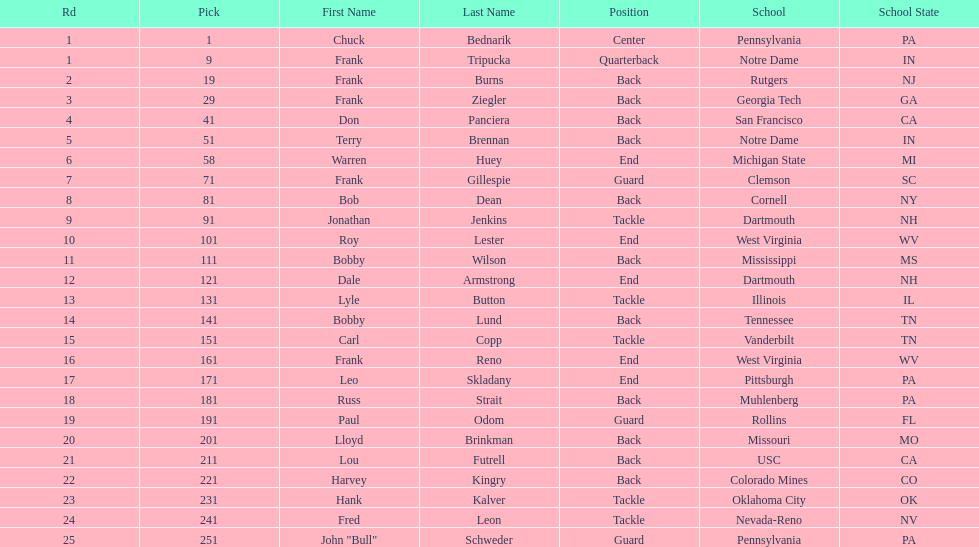What was the position that most of the players had? Back. Would you be able to parse every entry in this table? {'header': ['Rd', 'Pick', 'First Name', 'Last Name', 'Position', 'School', 'School State'], 'rows': [['1', '1', 'Chuck', 'Bednarik', 'Center', 'Pennsylvania', 'PA'], ['1', '9', 'Frank', 'Tripucka', 'Quarterback', 'Notre Dame', 'IN'], ['2', '19', 'Frank', 'Burns', 'Back', 'Rutgers', 'NJ'], ['3', '29', 'Frank', 'Ziegler', 'Back', 'Georgia Tech', 'GA'], ['4', '41', 'Don', 'Panciera', 'Back', 'San Francisco', 'CA'], ['5', '51', 'Terry', 'Brennan', 'Back', 'Notre Dame', 'IN'], ['6', '58', 'Warren', 'Huey', 'End', 'Michigan State', 'MI'], ['7', '71', 'Frank', 'Gillespie', 'Guard', 'Clemson', 'SC'], ['8', '81', 'Bob', 'Dean', 'Back', 'Cornell', 'NY'], ['9', '91', 'Jonathan', 'Jenkins', 'Tackle', 'Dartmouth', 'NH'], ['10', '101', 'Roy', 'Lester', 'End', 'West Virginia', 'WV'], ['11', '111', 'Bobby', 'Wilson', 'Back', 'Mississippi', 'MS'], ['12', '121', 'Dale', 'Armstrong', 'End', 'Dartmouth', 'NH'], ['13', '131', 'Lyle', 'Button', 'Tackle', 'Illinois', 'IL'], ['14', '141', 'Bobby', 'Lund', 'Back', 'Tennessee', 'TN'], ['15', '151', 'Carl', 'Copp', 'Tackle', 'Vanderbilt', 'TN'], ['16', '161', 'Frank', 'Reno', 'End', 'West Virginia', 'WV'], ['17', '171', 'Leo', 'Skladany', 'End', 'Pittsburgh', 'PA'], ['18', '181', 'Russ', 'Strait', 'Back', 'Muhlenberg', 'PA'], ['19', '191', 'Paul', 'Odom', 'Guard', 'Rollins', 'FL'], ['20', '201', 'Lloyd', 'Brinkman', 'Back', 'Missouri', 'MO'], ['21', '211', 'Lou', 'Futrell', 'Back', 'USC', 'CA'], ['22', '221', 'Harvey', 'Kingry', 'Back', 'Colorado Mines', 'CO'], ['23', '231', 'Hank', 'Kalver', 'Tackle', 'Oklahoma City', 'OK'], ['24', '241', 'Fred', 'Leon', 'Tackle', 'Nevada-Reno', 'NV'], ['25', '251', 'John "Bull"', 'Schweder', 'Guard', 'Pennsylvania', 'PA']]} 